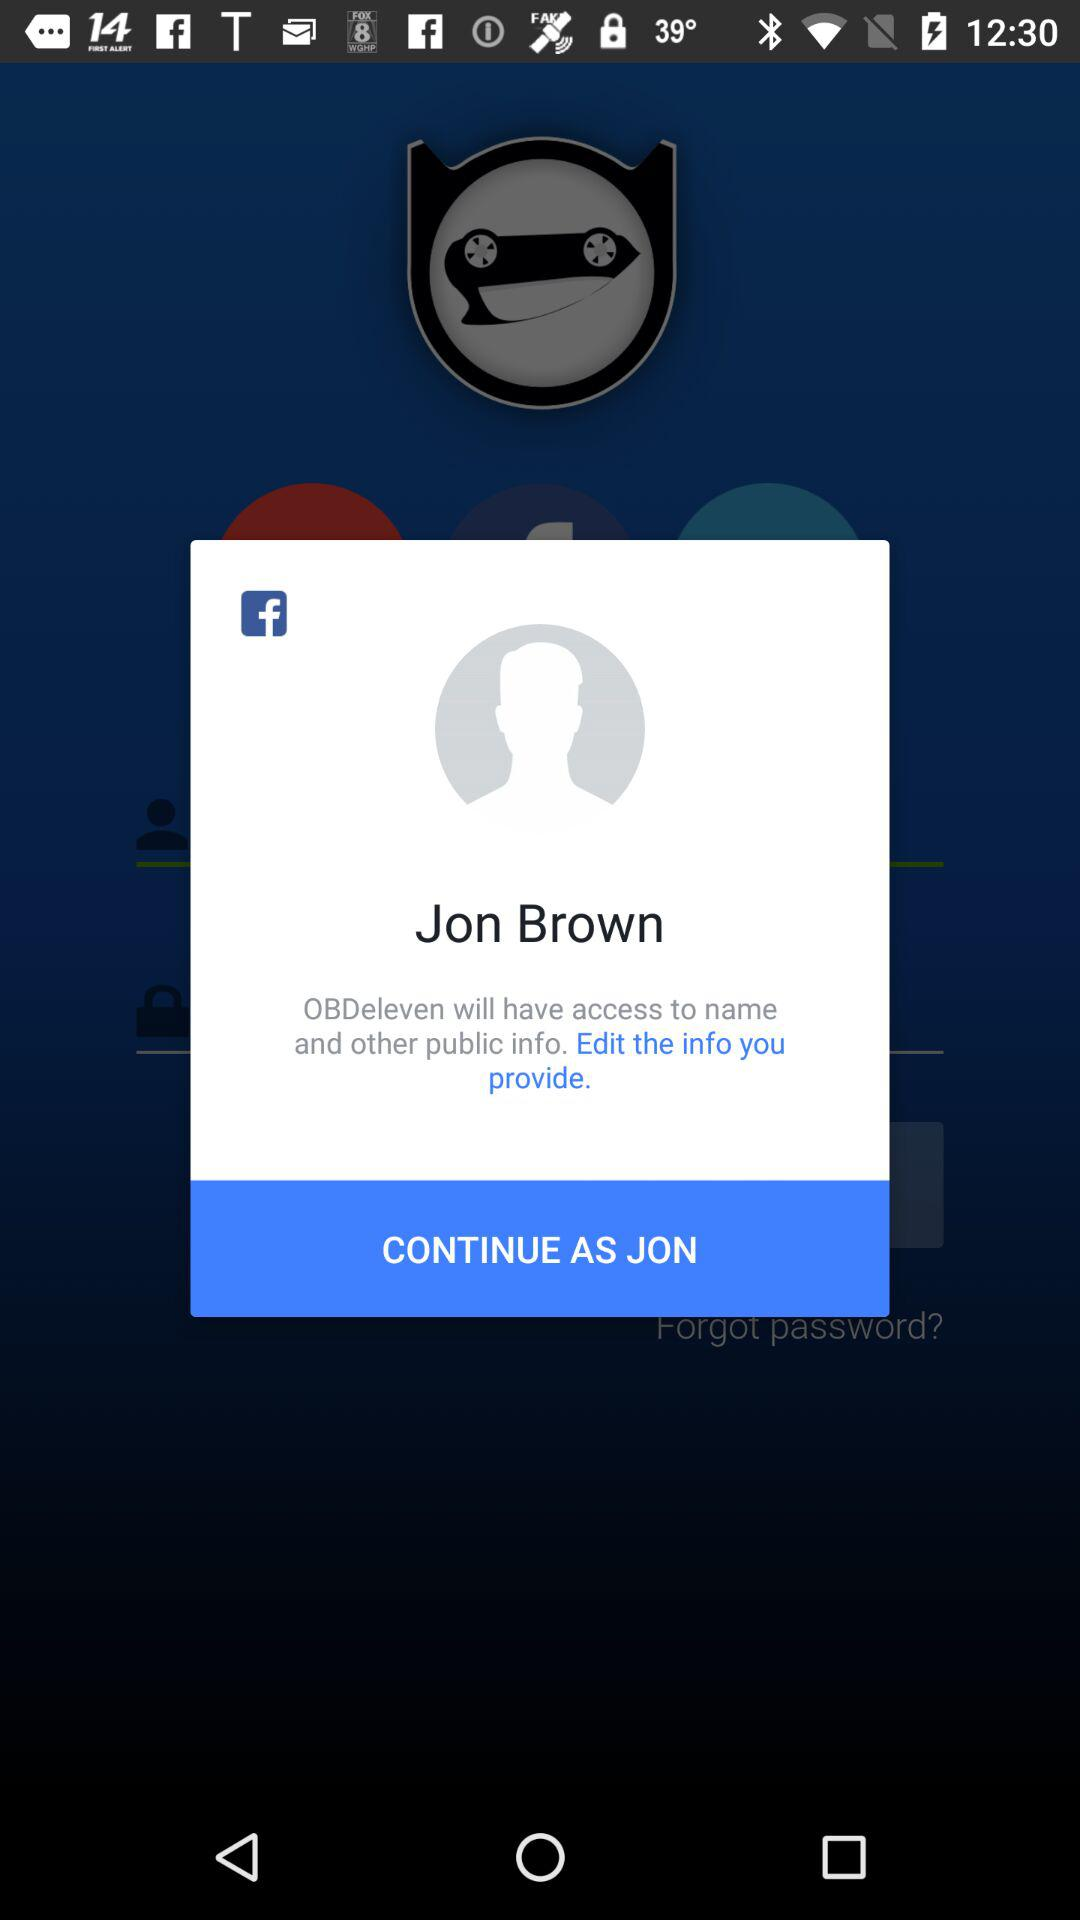What is the user's name? The user name is Jon Brown. 